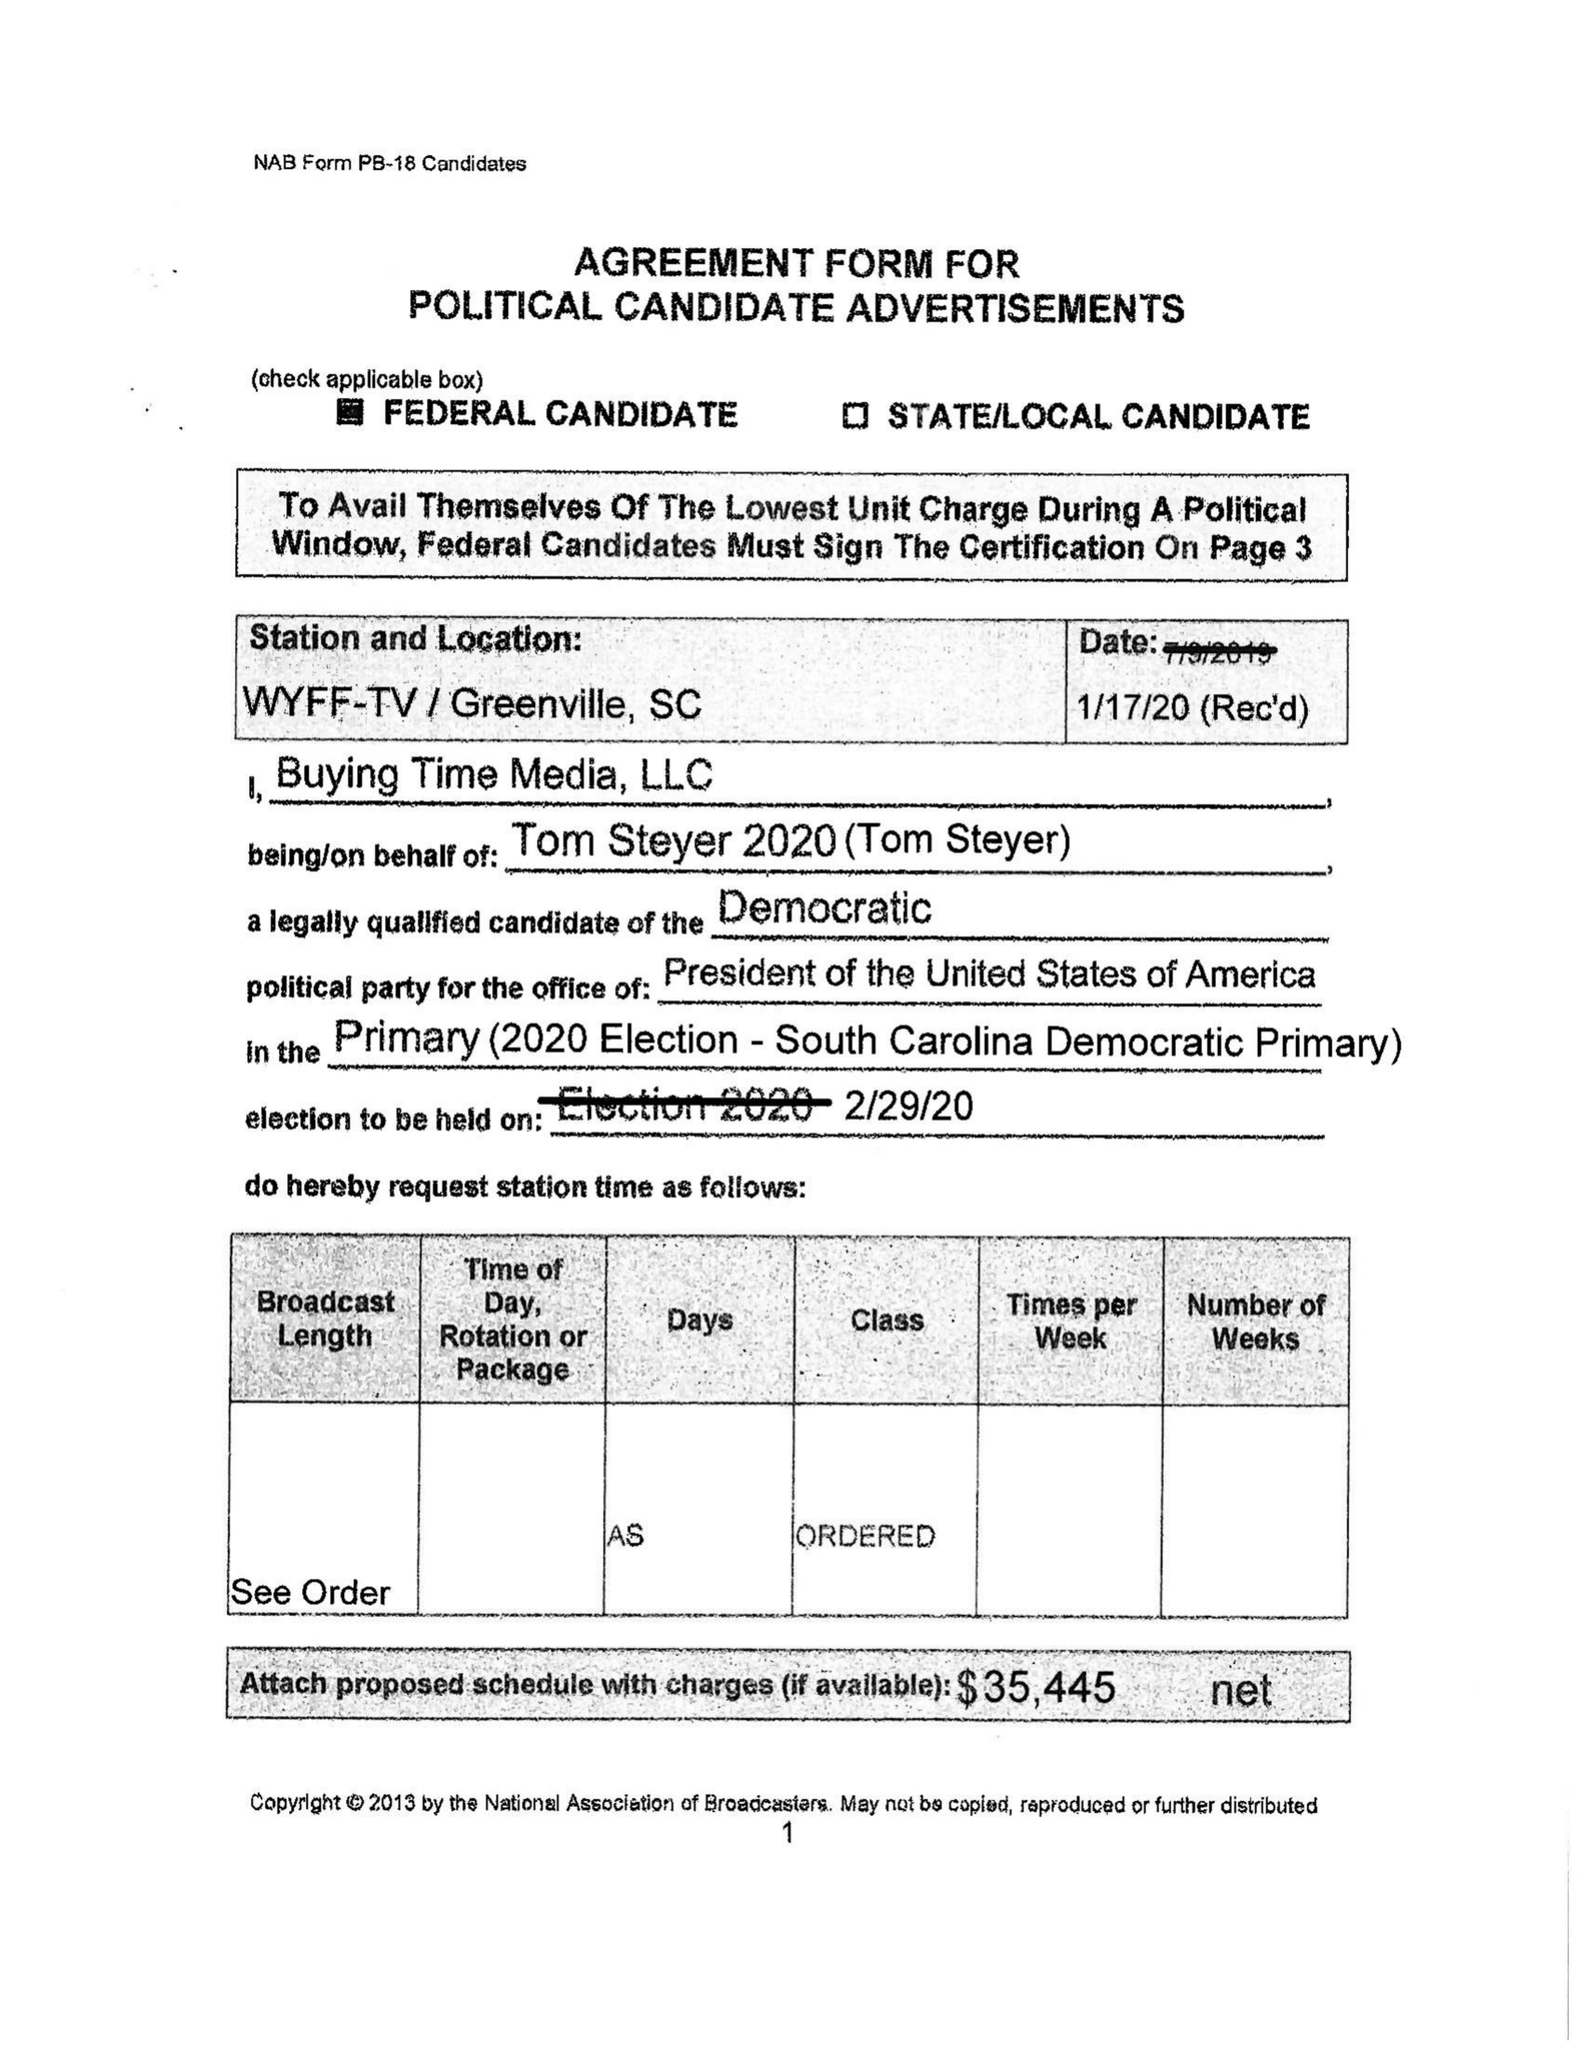What is the value for the gross_amount?
Answer the question using a single word or phrase. 35445.00 